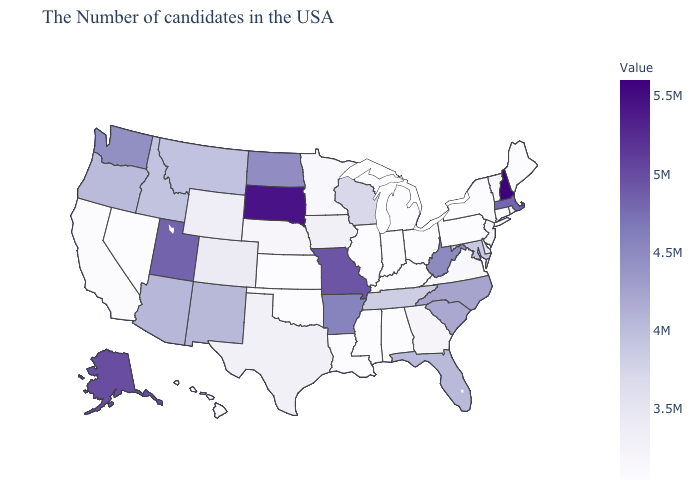Does Hawaii have the lowest value in the West?
Concise answer only. Yes. Among the states that border Kansas , does Missouri have the highest value?
Quick response, please. Yes. 